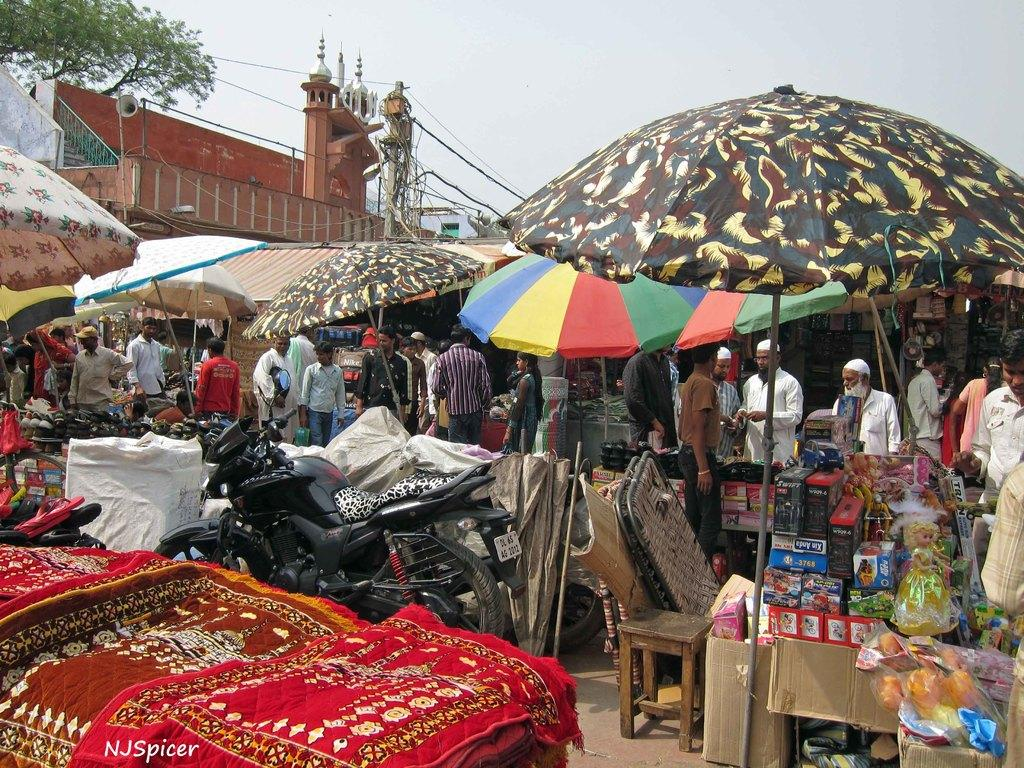What objects are present in the image that provide protection from the elements? There are umbrellas in the image that provide protection from the elements. What types of transportation can be seen in the image? There are vehicles in the image. What items are present in the image that can be used for sitting or standing on? There are mats and a stool in the image that can be used for sitting or standing on. What objects are present in the image that can be used for storage? There are boxes in the image that can be used for storage. How many people are visible in the image? There are people in the image. What structures can be seen in the background of the image? In the background, there is a mosque, and there are three unspecified objects. What objects related to communication can be seen in the background of the image? There is a mic in the background. What objects related to electricity can be seen in the background of the image? There is a current pole and cables in the background. What type of caption is written on the umbrellas in the image? There is no caption written on the umbrellas in the image. What type of war is depicted in the image? There is no war depicted in the image. Are any people wearing masks in the image? There is no mention of masks or people wearing masks in the image. 